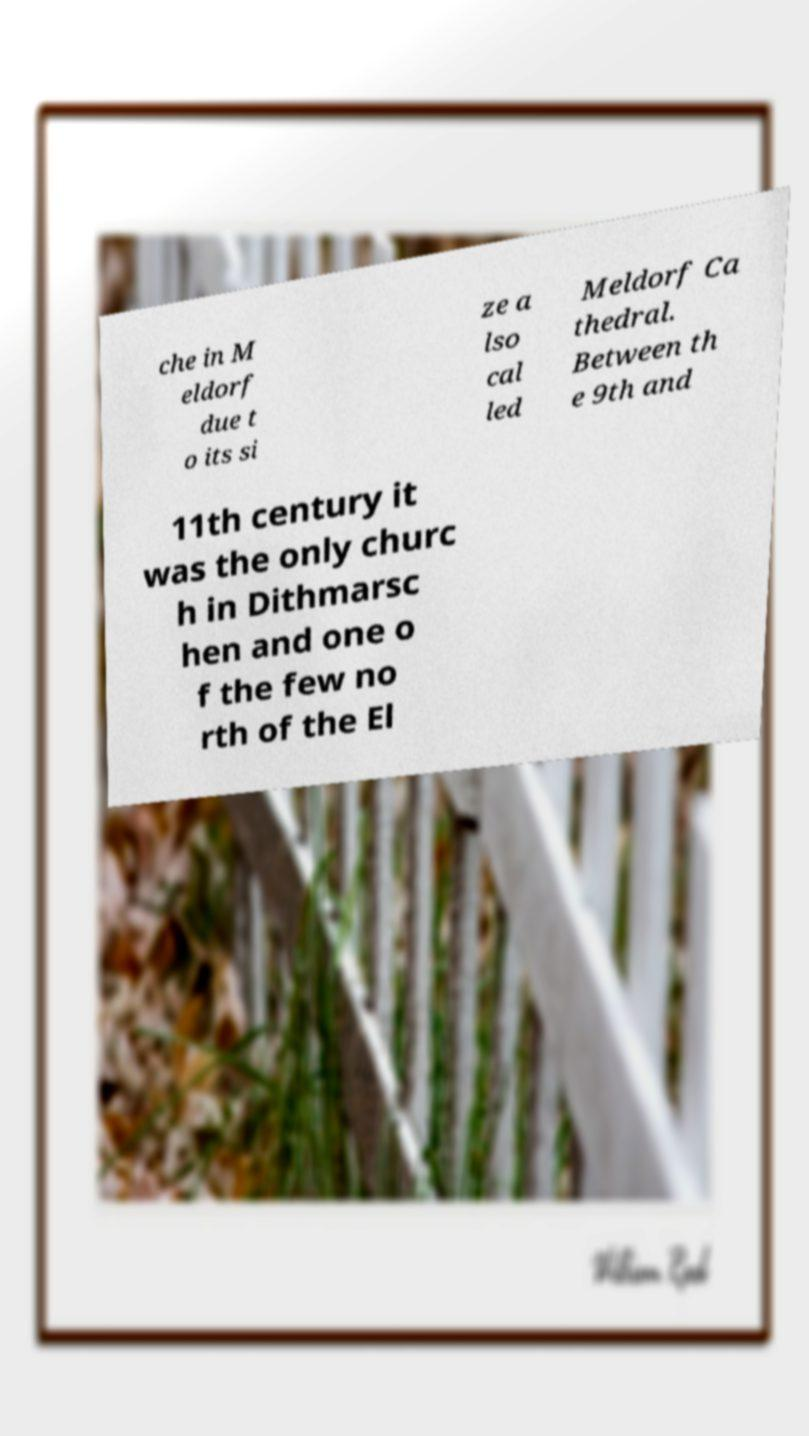There's text embedded in this image that I need extracted. Can you transcribe it verbatim? che in M eldorf due t o its si ze a lso cal led Meldorf Ca thedral. Between th e 9th and 11th century it was the only churc h in Dithmarsc hen and one o f the few no rth of the El 